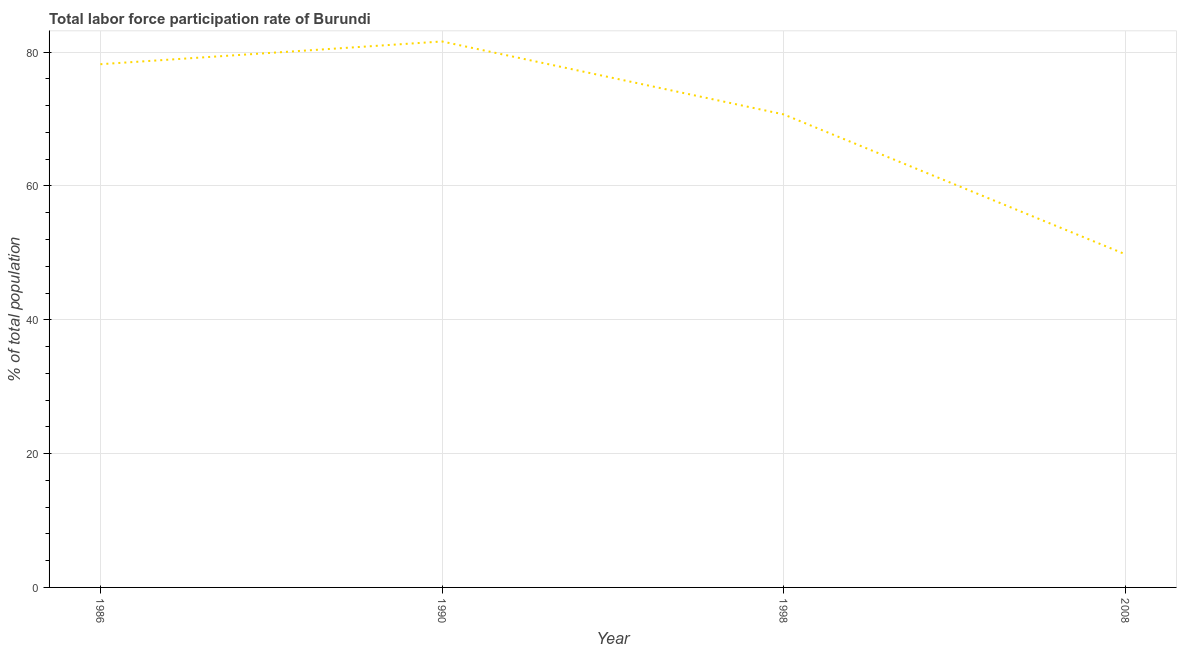What is the total labor force participation rate in 1998?
Give a very brief answer. 70.7. Across all years, what is the maximum total labor force participation rate?
Keep it short and to the point. 81.6. Across all years, what is the minimum total labor force participation rate?
Your response must be concise. 49.8. In which year was the total labor force participation rate maximum?
Provide a short and direct response. 1990. What is the sum of the total labor force participation rate?
Your answer should be compact. 280.3. What is the difference between the total labor force participation rate in 1986 and 1990?
Your answer should be very brief. -3.4. What is the average total labor force participation rate per year?
Provide a succinct answer. 70.07. What is the median total labor force participation rate?
Offer a terse response. 74.45. In how many years, is the total labor force participation rate greater than 64 %?
Provide a succinct answer. 3. What is the ratio of the total labor force participation rate in 1990 to that in 1998?
Keep it short and to the point. 1.15. Is the total labor force participation rate in 1986 less than that in 2008?
Give a very brief answer. No. What is the difference between the highest and the second highest total labor force participation rate?
Make the answer very short. 3.4. Is the sum of the total labor force participation rate in 1990 and 2008 greater than the maximum total labor force participation rate across all years?
Give a very brief answer. Yes. What is the difference between the highest and the lowest total labor force participation rate?
Ensure brevity in your answer.  31.8. Does the total labor force participation rate monotonically increase over the years?
Offer a very short reply. No. How many lines are there?
Provide a short and direct response. 1. What is the difference between two consecutive major ticks on the Y-axis?
Ensure brevity in your answer.  20. Are the values on the major ticks of Y-axis written in scientific E-notation?
Your response must be concise. No. What is the title of the graph?
Your answer should be very brief. Total labor force participation rate of Burundi. What is the label or title of the X-axis?
Your answer should be compact. Year. What is the label or title of the Y-axis?
Give a very brief answer. % of total population. What is the % of total population of 1986?
Give a very brief answer. 78.2. What is the % of total population of 1990?
Ensure brevity in your answer.  81.6. What is the % of total population in 1998?
Offer a very short reply. 70.7. What is the % of total population of 2008?
Make the answer very short. 49.8. What is the difference between the % of total population in 1986 and 1998?
Offer a terse response. 7.5. What is the difference between the % of total population in 1986 and 2008?
Your response must be concise. 28.4. What is the difference between the % of total population in 1990 and 1998?
Your answer should be very brief. 10.9. What is the difference between the % of total population in 1990 and 2008?
Give a very brief answer. 31.8. What is the difference between the % of total population in 1998 and 2008?
Your response must be concise. 20.9. What is the ratio of the % of total population in 1986 to that in 1990?
Give a very brief answer. 0.96. What is the ratio of the % of total population in 1986 to that in 1998?
Provide a short and direct response. 1.11. What is the ratio of the % of total population in 1986 to that in 2008?
Your answer should be very brief. 1.57. What is the ratio of the % of total population in 1990 to that in 1998?
Your response must be concise. 1.15. What is the ratio of the % of total population in 1990 to that in 2008?
Give a very brief answer. 1.64. What is the ratio of the % of total population in 1998 to that in 2008?
Keep it short and to the point. 1.42. 